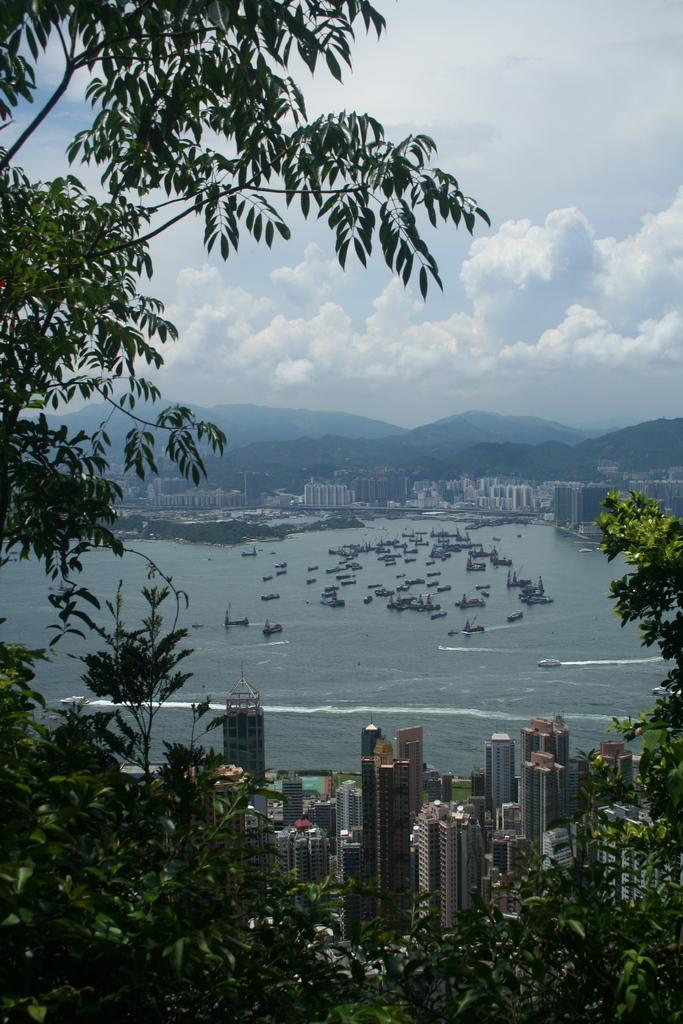What type of structures can be seen in the image? There are buildings in the image. What natural elements are present in the image? There are trees and mountains in the image. What mode of transportation can be seen in the image? There are ships in the image. What type of terrain is visible in the image? There are mountains and water visible in the image. What is the color of the sky in the image? The sky is blue and white in color. What is the opinion of the trees about the birth of the base in the image? There is no mention of a base or any opinions in the image; it features buildings, trees, ships, mountains, water, and a blue and white sky. 